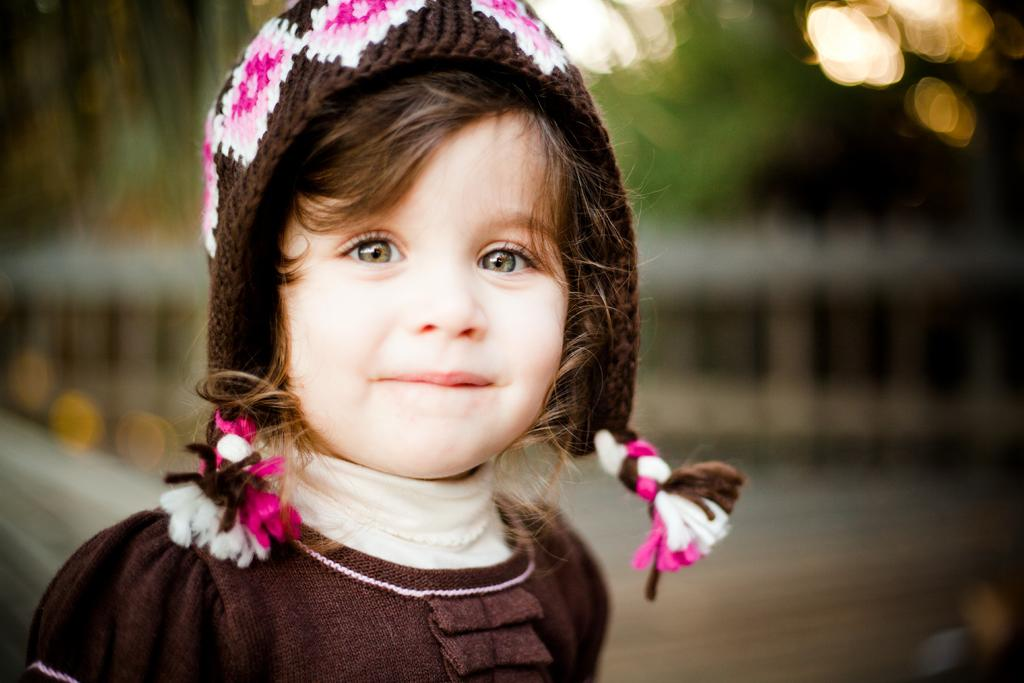Who is the main subject in the image? There is a girl in the image. What is the girl doing in the image? The girl is smiling. What is the girl wearing in the image? The girl is wearing a brown dress and a cap on her head. Can you describe the background of the image? The background of the image is blurred. What type of owl can be seen perched on the girl's shoulder in the image? There is no owl present in the image; the girl is wearing a cap on her head. How does the girl wave to the camera in the image? The girl is not waving in the image; she is smiling. 